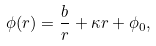Convert formula to latex. <formula><loc_0><loc_0><loc_500><loc_500>\phi ( r ) = \frac { b } { r } + \kappa r + \phi _ { 0 } ,</formula> 